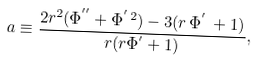Convert formula to latex. <formula><loc_0><loc_0><loc_500><loc_500>a \equiv \frac { 2 r ^ { 2 } ( \Phi ^ { ^ { \prime \prime } } + \Phi ^ { ^ { \prime } \, 2 } ) - 3 ( r \, \Phi ^ { ^ { \prime } } \, + 1 ) } { r ( r \Phi ^ { ^ { \prime } } + 1 ) } ,</formula> 